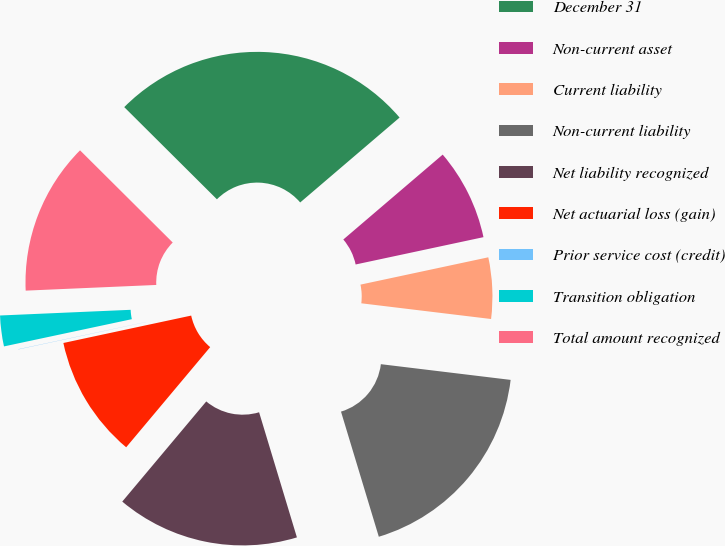Convert chart to OTSL. <chart><loc_0><loc_0><loc_500><loc_500><pie_chart><fcel>December 31<fcel>Non-current asset<fcel>Current liability<fcel>Non-current liability<fcel>Net liability recognized<fcel>Net actuarial loss (gain)<fcel>Prior service cost (credit)<fcel>Transition obligation<fcel>Total amount recognized<nl><fcel>26.29%<fcel>7.9%<fcel>5.27%<fcel>18.41%<fcel>15.78%<fcel>10.53%<fcel>0.02%<fcel>2.65%<fcel>13.15%<nl></chart> 